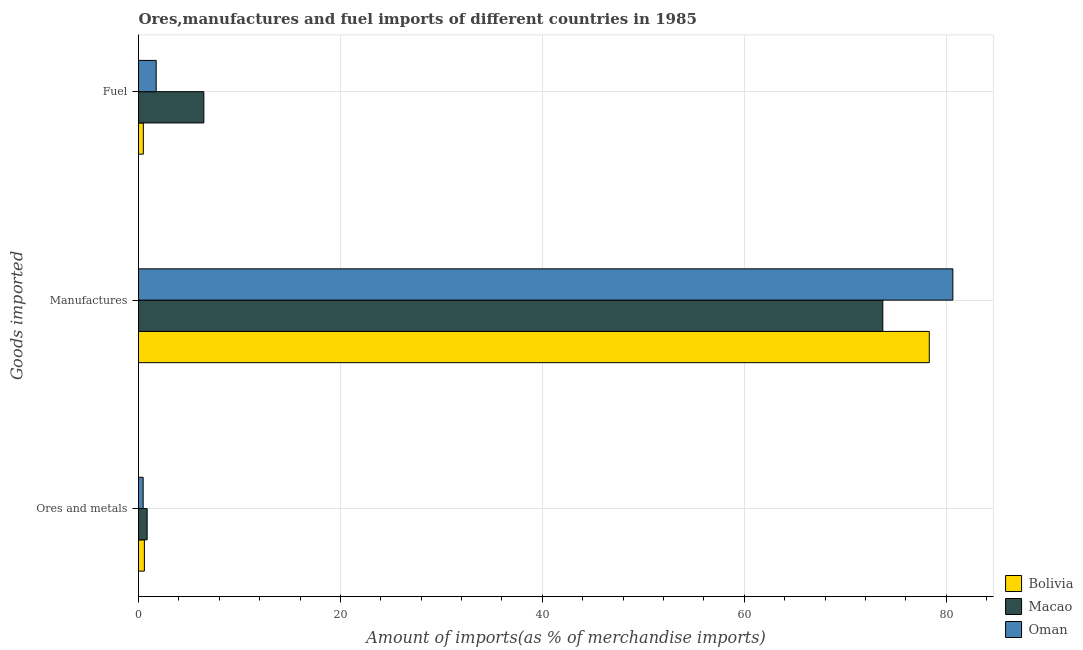How many groups of bars are there?
Your answer should be compact. 3. Are the number of bars on each tick of the Y-axis equal?
Offer a terse response. Yes. How many bars are there on the 2nd tick from the top?
Offer a terse response. 3. What is the label of the 2nd group of bars from the top?
Your answer should be compact. Manufactures. What is the percentage of manufactures imports in Macao?
Ensure brevity in your answer.  73.72. Across all countries, what is the maximum percentage of fuel imports?
Make the answer very short. 6.47. Across all countries, what is the minimum percentage of fuel imports?
Your response must be concise. 0.48. In which country was the percentage of manufactures imports maximum?
Your response must be concise. Oman. In which country was the percentage of ores and metals imports minimum?
Your response must be concise. Oman. What is the total percentage of ores and metals imports in the graph?
Provide a succinct answer. 1.9. What is the difference between the percentage of fuel imports in Macao and that in Oman?
Your answer should be compact. 4.72. What is the difference between the percentage of manufactures imports in Oman and the percentage of ores and metals imports in Macao?
Your response must be concise. 79.81. What is the average percentage of manufactures imports per country?
Your answer should be very brief. 77.57. What is the difference between the percentage of manufactures imports and percentage of ores and metals imports in Oman?
Offer a terse response. 80.2. In how many countries, is the percentage of manufactures imports greater than 76 %?
Your answer should be compact. 2. What is the ratio of the percentage of fuel imports in Macao to that in Oman?
Give a very brief answer. 3.7. Is the percentage of fuel imports in Bolivia less than that in Oman?
Provide a succinct answer. Yes. Is the difference between the percentage of ores and metals imports in Macao and Bolivia greater than the difference between the percentage of manufactures imports in Macao and Bolivia?
Keep it short and to the point. Yes. What is the difference between the highest and the second highest percentage of manufactures imports?
Keep it short and to the point. 2.34. What is the difference between the highest and the lowest percentage of fuel imports?
Your answer should be compact. 5.99. Is the sum of the percentage of fuel imports in Bolivia and Oman greater than the maximum percentage of manufactures imports across all countries?
Your answer should be compact. No. What does the 2nd bar from the top in Manufactures represents?
Your response must be concise. Macao. What does the 3rd bar from the bottom in Manufactures represents?
Your answer should be very brief. Oman. How many countries are there in the graph?
Offer a terse response. 3. What is the difference between two consecutive major ticks on the X-axis?
Offer a terse response. 20. Does the graph contain any zero values?
Ensure brevity in your answer.  No. Does the graph contain grids?
Give a very brief answer. Yes. Where does the legend appear in the graph?
Provide a short and direct response. Bottom right. How are the legend labels stacked?
Your response must be concise. Vertical. What is the title of the graph?
Give a very brief answer. Ores,manufactures and fuel imports of different countries in 1985. What is the label or title of the X-axis?
Your answer should be very brief. Amount of imports(as % of merchandise imports). What is the label or title of the Y-axis?
Offer a terse response. Goods imported. What is the Amount of imports(as % of merchandise imports) in Bolivia in Ores and metals?
Your answer should be very brief. 0.58. What is the Amount of imports(as % of merchandise imports) in Macao in Ores and metals?
Your response must be concise. 0.86. What is the Amount of imports(as % of merchandise imports) of Oman in Ores and metals?
Your answer should be compact. 0.46. What is the Amount of imports(as % of merchandise imports) in Bolivia in Manufactures?
Make the answer very short. 78.33. What is the Amount of imports(as % of merchandise imports) of Macao in Manufactures?
Provide a succinct answer. 73.72. What is the Amount of imports(as % of merchandise imports) of Oman in Manufactures?
Keep it short and to the point. 80.66. What is the Amount of imports(as % of merchandise imports) in Bolivia in Fuel?
Your response must be concise. 0.48. What is the Amount of imports(as % of merchandise imports) of Macao in Fuel?
Give a very brief answer. 6.47. What is the Amount of imports(as % of merchandise imports) in Oman in Fuel?
Keep it short and to the point. 1.75. Across all Goods imported, what is the maximum Amount of imports(as % of merchandise imports) of Bolivia?
Offer a terse response. 78.33. Across all Goods imported, what is the maximum Amount of imports(as % of merchandise imports) in Macao?
Your answer should be compact. 73.72. Across all Goods imported, what is the maximum Amount of imports(as % of merchandise imports) of Oman?
Provide a succinct answer. 80.66. Across all Goods imported, what is the minimum Amount of imports(as % of merchandise imports) of Bolivia?
Your answer should be compact. 0.48. Across all Goods imported, what is the minimum Amount of imports(as % of merchandise imports) of Macao?
Your answer should be very brief. 0.86. Across all Goods imported, what is the minimum Amount of imports(as % of merchandise imports) in Oman?
Keep it short and to the point. 0.46. What is the total Amount of imports(as % of merchandise imports) in Bolivia in the graph?
Your response must be concise. 79.39. What is the total Amount of imports(as % of merchandise imports) of Macao in the graph?
Your response must be concise. 81.05. What is the total Amount of imports(as % of merchandise imports) of Oman in the graph?
Offer a terse response. 82.87. What is the difference between the Amount of imports(as % of merchandise imports) in Bolivia in Ores and metals and that in Manufactures?
Offer a very short reply. -77.74. What is the difference between the Amount of imports(as % of merchandise imports) in Macao in Ores and metals and that in Manufactures?
Ensure brevity in your answer.  -72.87. What is the difference between the Amount of imports(as % of merchandise imports) of Oman in Ores and metals and that in Manufactures?
Provide a succinct answer. -80.2. What is the difference between the Amount of imports(as % of merchandise imports) in Bolivia in Ores and metals and that in Fuel?
Your response must be concise. 0.1. What is the difference between the Amount of imports(as % of merchandise imports) in Macao in Ores and metals and that in Fuel?
Give a very brief answer. -5.61. What is the difference between the Amount of imports(as % of merchandise imports) of Oman in Ores and metals and that in Fuel?
Offer a very short reply. -1.29. What is the difference between the Amount of imports(as % of merchandise imports) of Bolivia in Manufactures and that in Fuel?
Offer a very short reply. 77.85. What is the difference between the Amount of imports(as % of merchandise imports) of Macao in Manufactures and that in Fuel?
Your answer should be compact. 67.25. What is the difference between the Amount of imports(as % of merchandise imports) in Oman in Manufactures and that in Fuel?
Give a very brief answer. 78.91. What is the difference between the Amount of imports(as % of merchandise imports) of Bolivia in Ores and metals and the Amount of imports(as % of merchandise imports) of Macao in Manufactures?
Ensure brevity in your answer.  -73.14. What is the difference between the Amount of imports(as % of merchandise imports) in Bolivia in Ores and metals and the Amount of imports(as % of merchandise imports) in Oman in Manufactures?
Give a very brief answer. -80.08. What is the difference between the Amount of imports(as % of merchandise imports) in Macao in Ores and metals and the Amount of imports(as % of merchandise imports) in Oman in Manufactures?
Ensure brevity in your answer.  -79.81. What is the difference between the Amount of imports(as % of merchandise imports) in Bolivia in Ores and metals and the Amount of imports(as % of merchandise imports) in Macao in Fuel?
Provide a succinct answer. -5.89. What is the difference between the Amount of imports(as % of merchandise imports) of Bolivia in Ores and metals and the Amount of imports(as % of merchandise imports) of Oman in Fuel?
Make the answer very short. -1.17. What is the difference between the Amount of imports(as % of merchandise imports) in Macao in Ores and metals and the Amount of imports(as % of merchandise imports) in Oman in Fuel?
Make the answer very short. -0.89. What is the difference between the Amount of imports(as % of merchandise imports) of Bolivia in Manufactures and the Amount of imports(as % of merchandise imports) of Macao in Fuel?
Provide a short and direct response. 71.86. What is the difference between the Amount of imports(as % of merchandise imports) in Bolivia in Manufactures and the Amount of imports(as % of merchandise imports) in Oman in Fuel?
Provide a succinct answer. 76.58. What is the difference between the Amount of imports(as % of merchandise imports) of Macao in Manufactures and the Amount of imports(as % of merchandise imports) of Oman in Fuel?
Provide a short and direct response. 71.97. What is the average Amount of imports(as % of merchandise imports) in Bolivia per Goods imported?
Provide a succinct answer. 26.46. What is the average Amount of imports(as % of merchandise imports) in Macao per Goods imported?
Offer a terse response. 27.02. What is the average Amount of imports(as % of merchandise imports) of Oman per Goods imported?
Your answer should be compact. 27.62. What is the difference between the Amount of imports(as % of merchandise imports) of Bolivia and Amount of imports(as % of merchandise imports) of Macao in Ores and metals?
Provide a succinct answer. -0.27. What is the difference between the Amount of imports(as % of merchandise imports) of Bolivia and Amount of imports(as % of merchandise imports) of Oman in Ores and metals?
Give a very brief answer. 0.12. What is the difference between the Amount of imports(as % of merchandise imports) in Macao and Amount of imports(as % of merchandise imports) in Oman in Ores and metals?
Ensure brevity in your answer.  0.4. What is the difference between the Amount of imports(as % of merchandise imports) of Bolivia and Amount of imports(as % of merchandise imports) of Macao in Manufactures?
Provide a short and direct response. 4.6. What is the difference between the Amount of imports(as % of merchandise imports) in Bolivia and Amount of imports(as % of merchandise imports) in Oman in Manufactures?
Give a very brief answer. -2.34. What is the difference between the Amount of imports(as % of merchandise imports) of Macao and Amount of imports(as % of merchandise imports) of Oman in Manufactures?
Provide a succinct answer. -6.94. What is the difference between the Amount of imports(as % of merchandise imports) of Bolivia and Amount of imports(as % of merchandise imports) of Macao in Fuel?
Ensure brevity in your answer.  -5.99. What is the difference between the Amount of imports(as % of merchandise imports) of Bolivia and Amount of imports(as % of merchandise imports) of Oman in Fuel?
Keep it short and to the point. -1.27. What is the difference between the Amount of imports(as % of merchandise imports) in Macao and Amount of imports(as % of merchandise imports) in Oman in Fuel?
Your answer should be very brief. 4.72. What is the ratio of the Amount of imports(as % of merchandise imports) of Bolivia in Ores and metals to that in Manufactures?
Offer a terse response. 0.01. What is the ratio of the Amount of imports(as % of merchandise imports) in Macao in Ores and metals to that in Manufactures?
Offer a very short reply. 0.01. What is the ratio of the Amount of imports(as % of merchandise imports) of Oman in Ores and metals to that in Manufactures?
Give a very brief answer. 0.01. What is the ratio of the Amount of imports(as % of merchandise imports) in Bolivia in Ores and metals to that in Fuel?
Your answer should be very brief. 1.22. What is the ratio of the Amount of imports(as % of merchandise imports) in Macao in Ores and metals to that in Fuel?
Provide a succinct answer. 0.13. What is the ratio of the Amount of imports(as % of merchandise imports) in Oman in Ores and metals to that in Fuel?
Your answer should be compact. 0.26. What is the ratio of the Amount of imports(as % of merchandise imports) in Bolivia in Manufactures to that in Fuel?
Your answer should be compact. 163.52. What is the ratio of the Amount of imports(as % of merchandise imports) of Macao in Manufactures to that in Fuel?
Your response must be concise. 11.39. What is the ratio of the Amount of imports(as % of merchandise imports) in Oman in Manufactures to that in Fuel?
Your response must be concise. 46.07. What is the difference between the highest and the second highest Amount of imports(as % of merchandise imports) in Bolivia?
Keep it short and to the point. 77.74. What is the difference between the highest and the second highest Amount of imports(as % of merchandise imports) in Macao?
Keep it short and to the point. 67.25. What is the difference between the highest and the second highest Amount of imports(as % of merchandise imports) in Oman?
Make the answer very short. 78.91. What is the difference between the highest and the lowest Amount of imports(as % of merchandise imports) in Bolivia?
Provide a succinct answer. 77.85. What is the difference between the highest and the lowest Amount of imports(as % of merchandise imports) in Macao?
Provide a succinct answer. 72.87. What is the difference between the highest and the lowest Amount of imports(as % of merchandise imports) of Oman?
Provide a short and direct response. 80.2. 